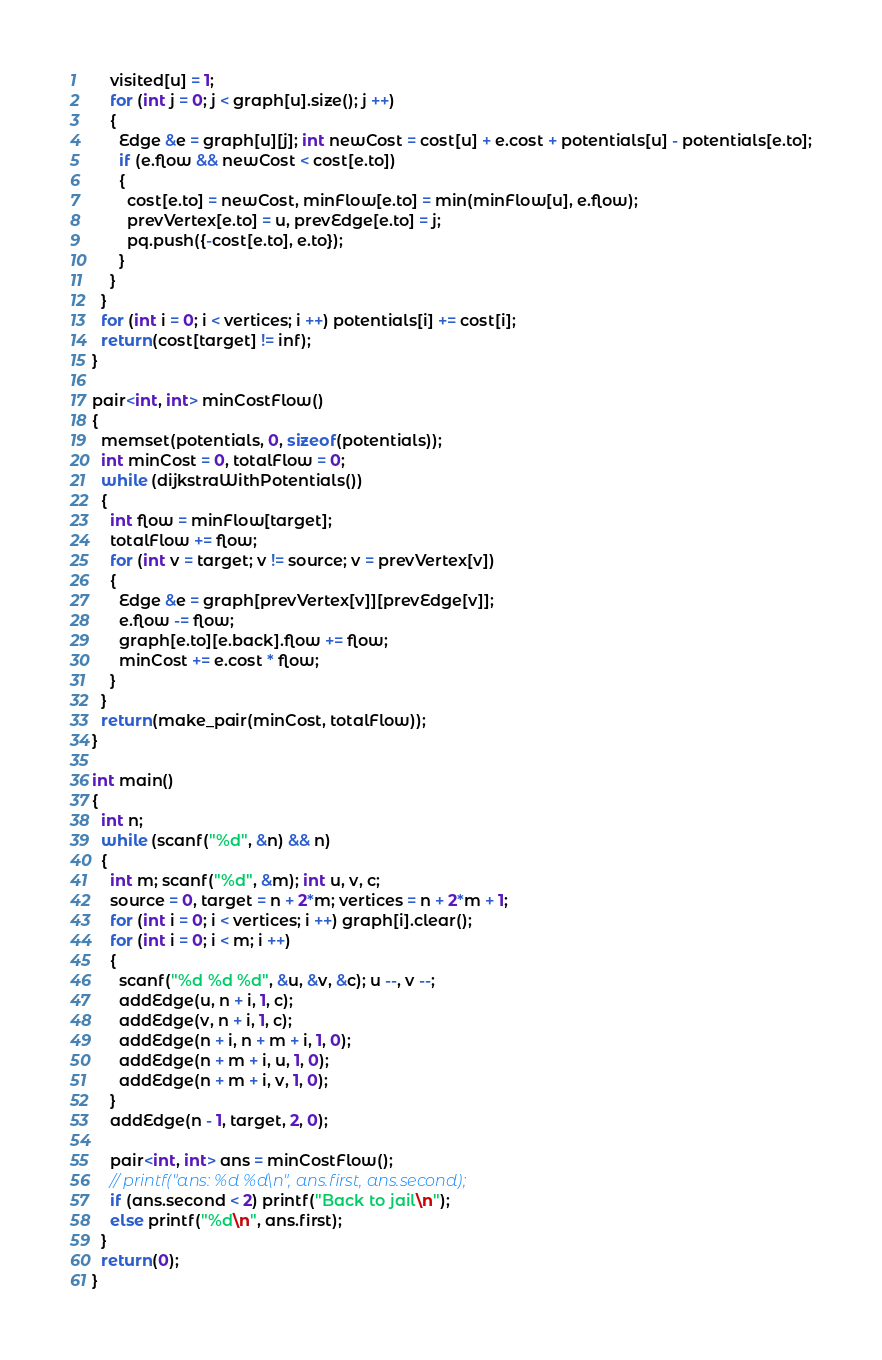<code> <loc_0><loc_0><loc_500><loc_500><_C++_>    visited[u] = 1;
    for (int j = 0; j < graph[u].size(); j ++)
    {
      Edge &e = graph[u][j]; int newCost = cost[u] + e.cost + potentials[u] - potentials[e.to];
      if (e.flow && newCost < cost[e.to])
      {
        cost[e.to] = newCost, minFlow[e.to] = min(minFlow[u], e.flow);
        prevVertex[e.to] = u, prevEdge[e.to] = j;
        pq.push({-cost[e.to], e.to});
      }
    }
  }
  for (int i = 0; i < vertices; i ++) potentials[i] += cost[i];
  return(cost[target] != inf);
}

pair<int, int> minCostFlow()
{
  memset(potentials, 0, sizeof(potentials));
  int minCost = 0, totalFlow = 0;
  while (dijkstraWithPotentials())
  {
    int flow = minFlow[target];
    totalFlow += flow;
    for (int v = target; v != source; v = prevVertex[v])
    {
      Edge &e = graph[prevVertex[v]][prevEdge[v]];
      e.flow -= flow;
      graph[e.to][e.back].flow += flow;
      minCost += e.cost * flow;
    }
  }
  return(make_pair(minCost, totalFlow));
}

int main()
{
  int n;
  while (scanf("%d", &n) && n)
  {
    int m; scanf("%d", &m); int u, v, c;
    source = 0, target = n + 2*m; vertices = n + 2*m + 1;
    for (int i = 0; i < vertices; i ++) graph[i].clear();
    for (int i = 0; i < m; i ++)
    {
      scanf("%d %d %d", &u, &v, &c); u --, v --;
      addEdge(u, n + i, 1, c);
      addEdge(v, n + i, 1, c);
      addEdge(n + i, n + m + i, 1, 0);
      addEdge(n + m + i, u, 1, 0);
      addEdge(n + m + i, v, 1, 0);
    }
    addEdge(n - 1, target, 2, 0);

    pair<int, int> ans = minCostFlow();
    // printf("ans: %d %d\n", ans.first, ans.second);
    if (ans.second < 2) printf("Back to jail\n");
    else printf("%d\n", ans.first);
  }
  return(0);
}
</code> 